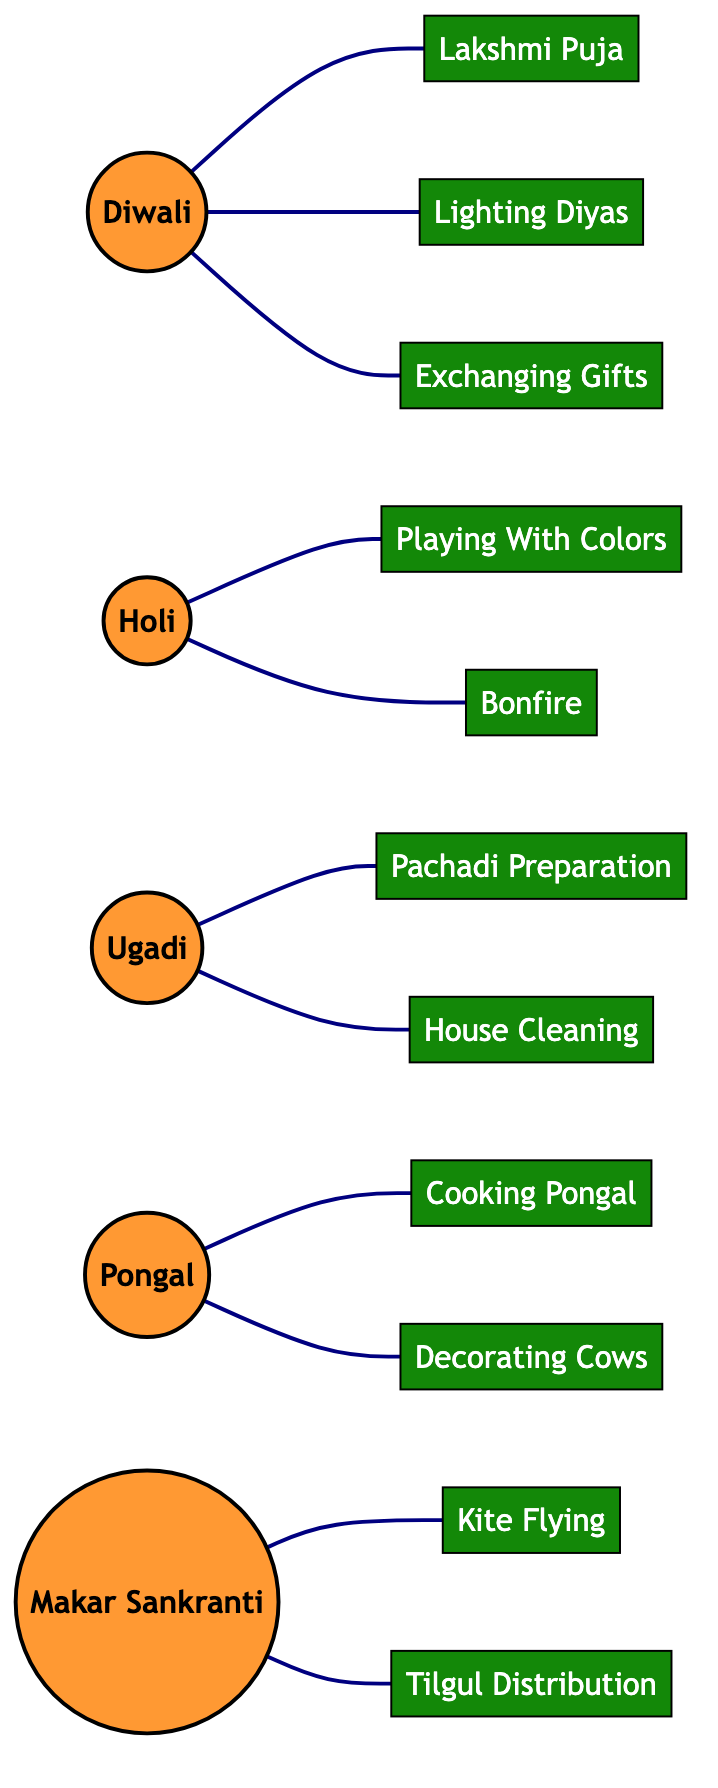What is the total number of festivals in the diagram? The diagram contains five festival nodes: Diwali, Holi, Ugadi, Pongal, and Makar Sankranti. Counting these, we find there are five festivals in total.
Answer: 5 Which ritual is associated with Diwali? There are three rituals connected to the Diwali festival: Lakshmi Puja, Lighting Diyas, and Exchanging Gifts. One specific ritual is Lakshmi Puja, which is directly linked to Diwali.
Answer: Lakshmi Puja How many edges are connected to Holi? The Holi festival has two edges connecting it to its associated rituals: Playing With Colors and Bonfire. Counting these edges gives us a total of two.
Answer: 2 What is the relationship between Pongal and Cooking Pongal? Pongal is directly connected to the ritual Cooking Pongal by an edge in the diagram. This indicates that Cooking Pongal is a key ritual performed during the Pongal festival.
Answer: Connected Which festival has the most associated rituals? Diwali has three associated rituals: Lakshmi Puja, Lighting Diyas, and Exchanging Gifts. No other festival has more rituals connected to it, making Diwali the festival with the most associated rituals.
Answer: Diwali How many rituals are linked to Makar Sankranti? Makar Sankranti is associated with two rituals: Kite Flying and Tilgul Distribution. There are no additional rituals connected to Makar Sankranti beyond these two.
Answer: 2 List all the festivals associated with the ritual of Decorating Cows. The only festival associated with the ritual of Decorating Cows is Pongal, as it is the only edge connecting them in the diagram.
Answer: Pongal Are there any festivals that involve house cleaning as a ritual? Yes, Ugadi is the festival that includes House Cleaning as one of its rituals, indicating that it is part of the key practices during Ugadi.
Answer: Ugadi Which ritual is uniquely associated with Ugadi? The ritual Pachadi Preparation is uniquely associated with Ugadi. It is directly connected to Ugadi without any other festivals sharing this ritual in the diagram.
Answer: Pachadi Preparation 